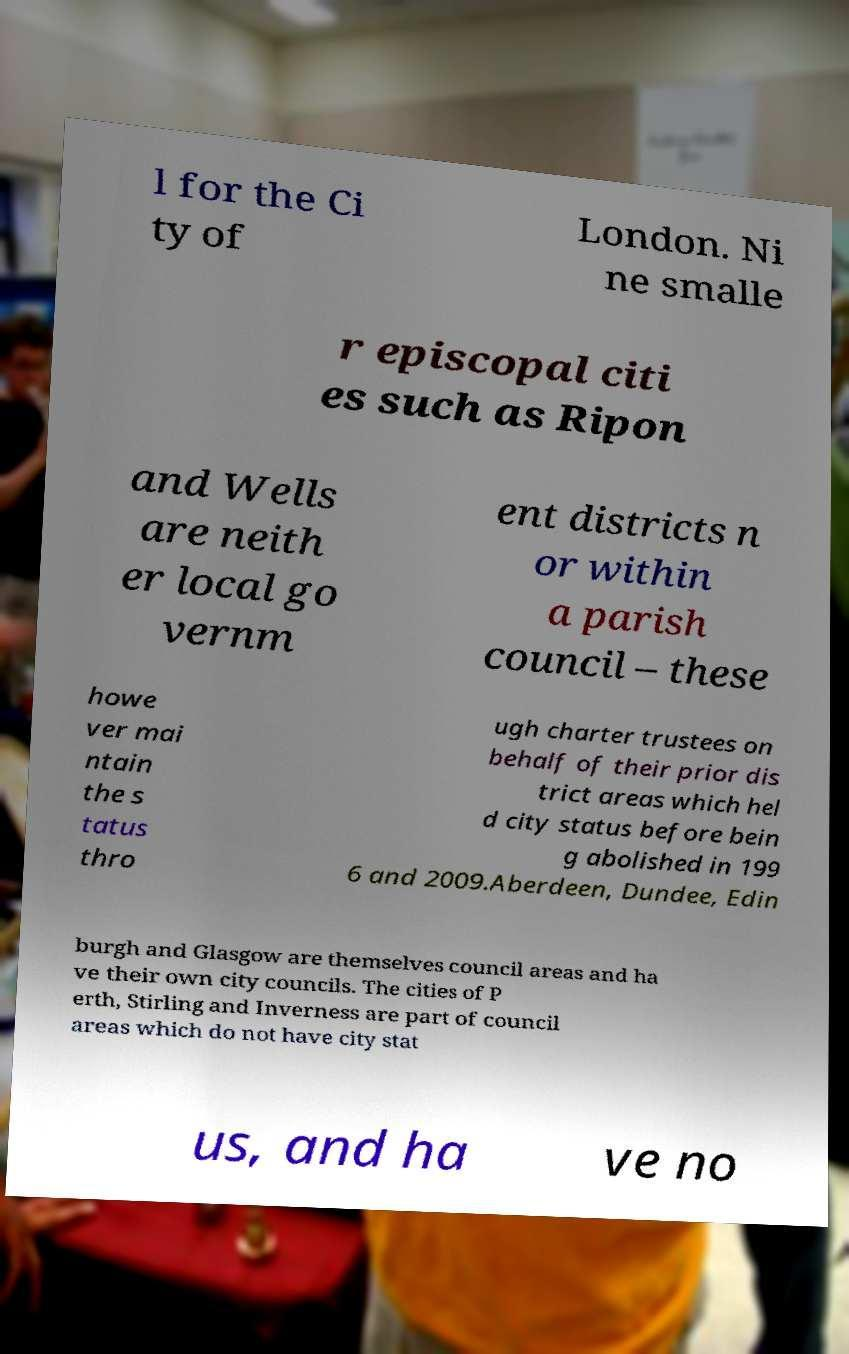Could you assist in decoding the text presented in this image and type it out clearly? l for the Ci ty of London. Ni ne smalle r episcopal citi es such as Ripon and Wells are neith er local go vernm ent districts n or within a parish council – these howe ver mai ntain the s tatus thro ugh charter trustees on behalf of their prior dis trict areas which hel d city status before bein g abolished in 199 6 and 2009.Aberdeen, Dundee, Edin burgh and Glasgow are themselves council areas and ha ve their own city councils. The cities of P erth, Stirling and Inverness are part of council areas which do not have city stat us, and ha ve no 